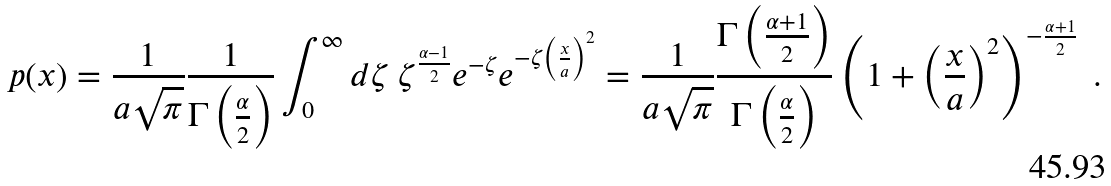Convert formula to latex. <formula><loc_0><loc_0><loc_500><loc_500>p ( x ) = \frac { 1 } { a \sqrt { \pi } } \frac { 1 } { \Gamma \left ( \frac { \alpha } { 2 } \right ) } \int _ { 0 } ^ { \infty } d \zeta \ \zeta ^ { \frac { \alpha - 1 } { 2 } } e ^ { - \zeta } e ^ { - \zeta \left ( \frac { x } { a } \right ) ^ { 2 } } = \frac { 1 } { a \sqrt { \pi } } \frac { \Gamma \left ( \frac { \alpha + 1 } { 2 } \right ) } { \Gamma \left ( \frac { \alpha } { 2 } \right ) } \left ( 1 + \left ( \frac { x } { a } \right ) ^ { 2 } \right ) ^ { - \frac { \alpha + 1 } { 2 } } \ .</formula> 